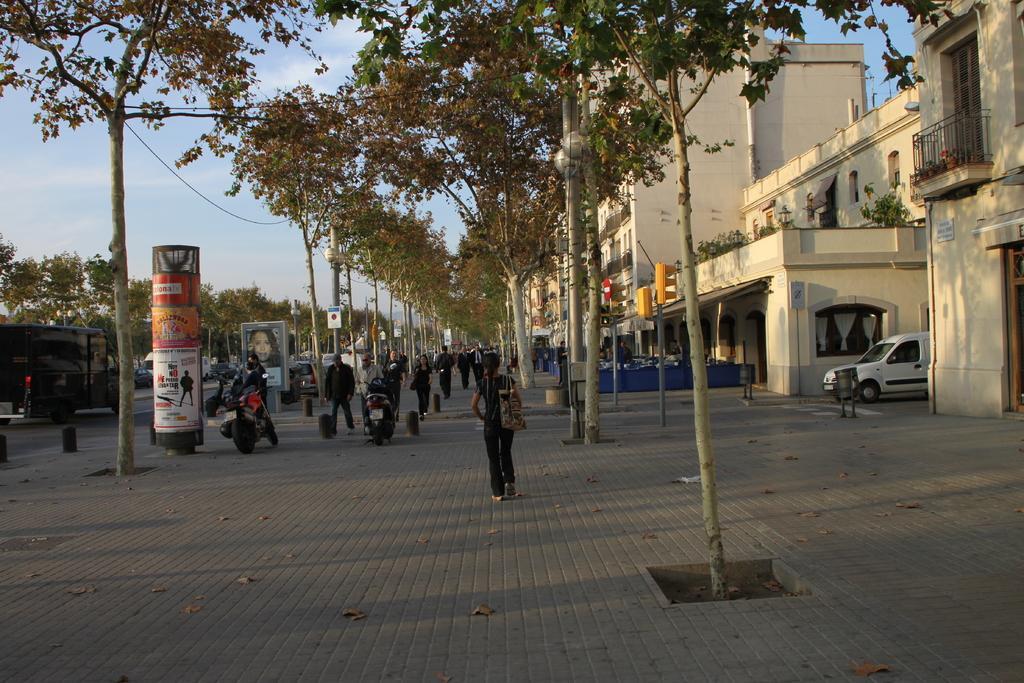Could you give a brief overview of what you see in this image? In this picture there are people in the center of the image and there are trees, buildings, posters, vehicles, and poles in the background area of the image, it seems to be the road side view. 